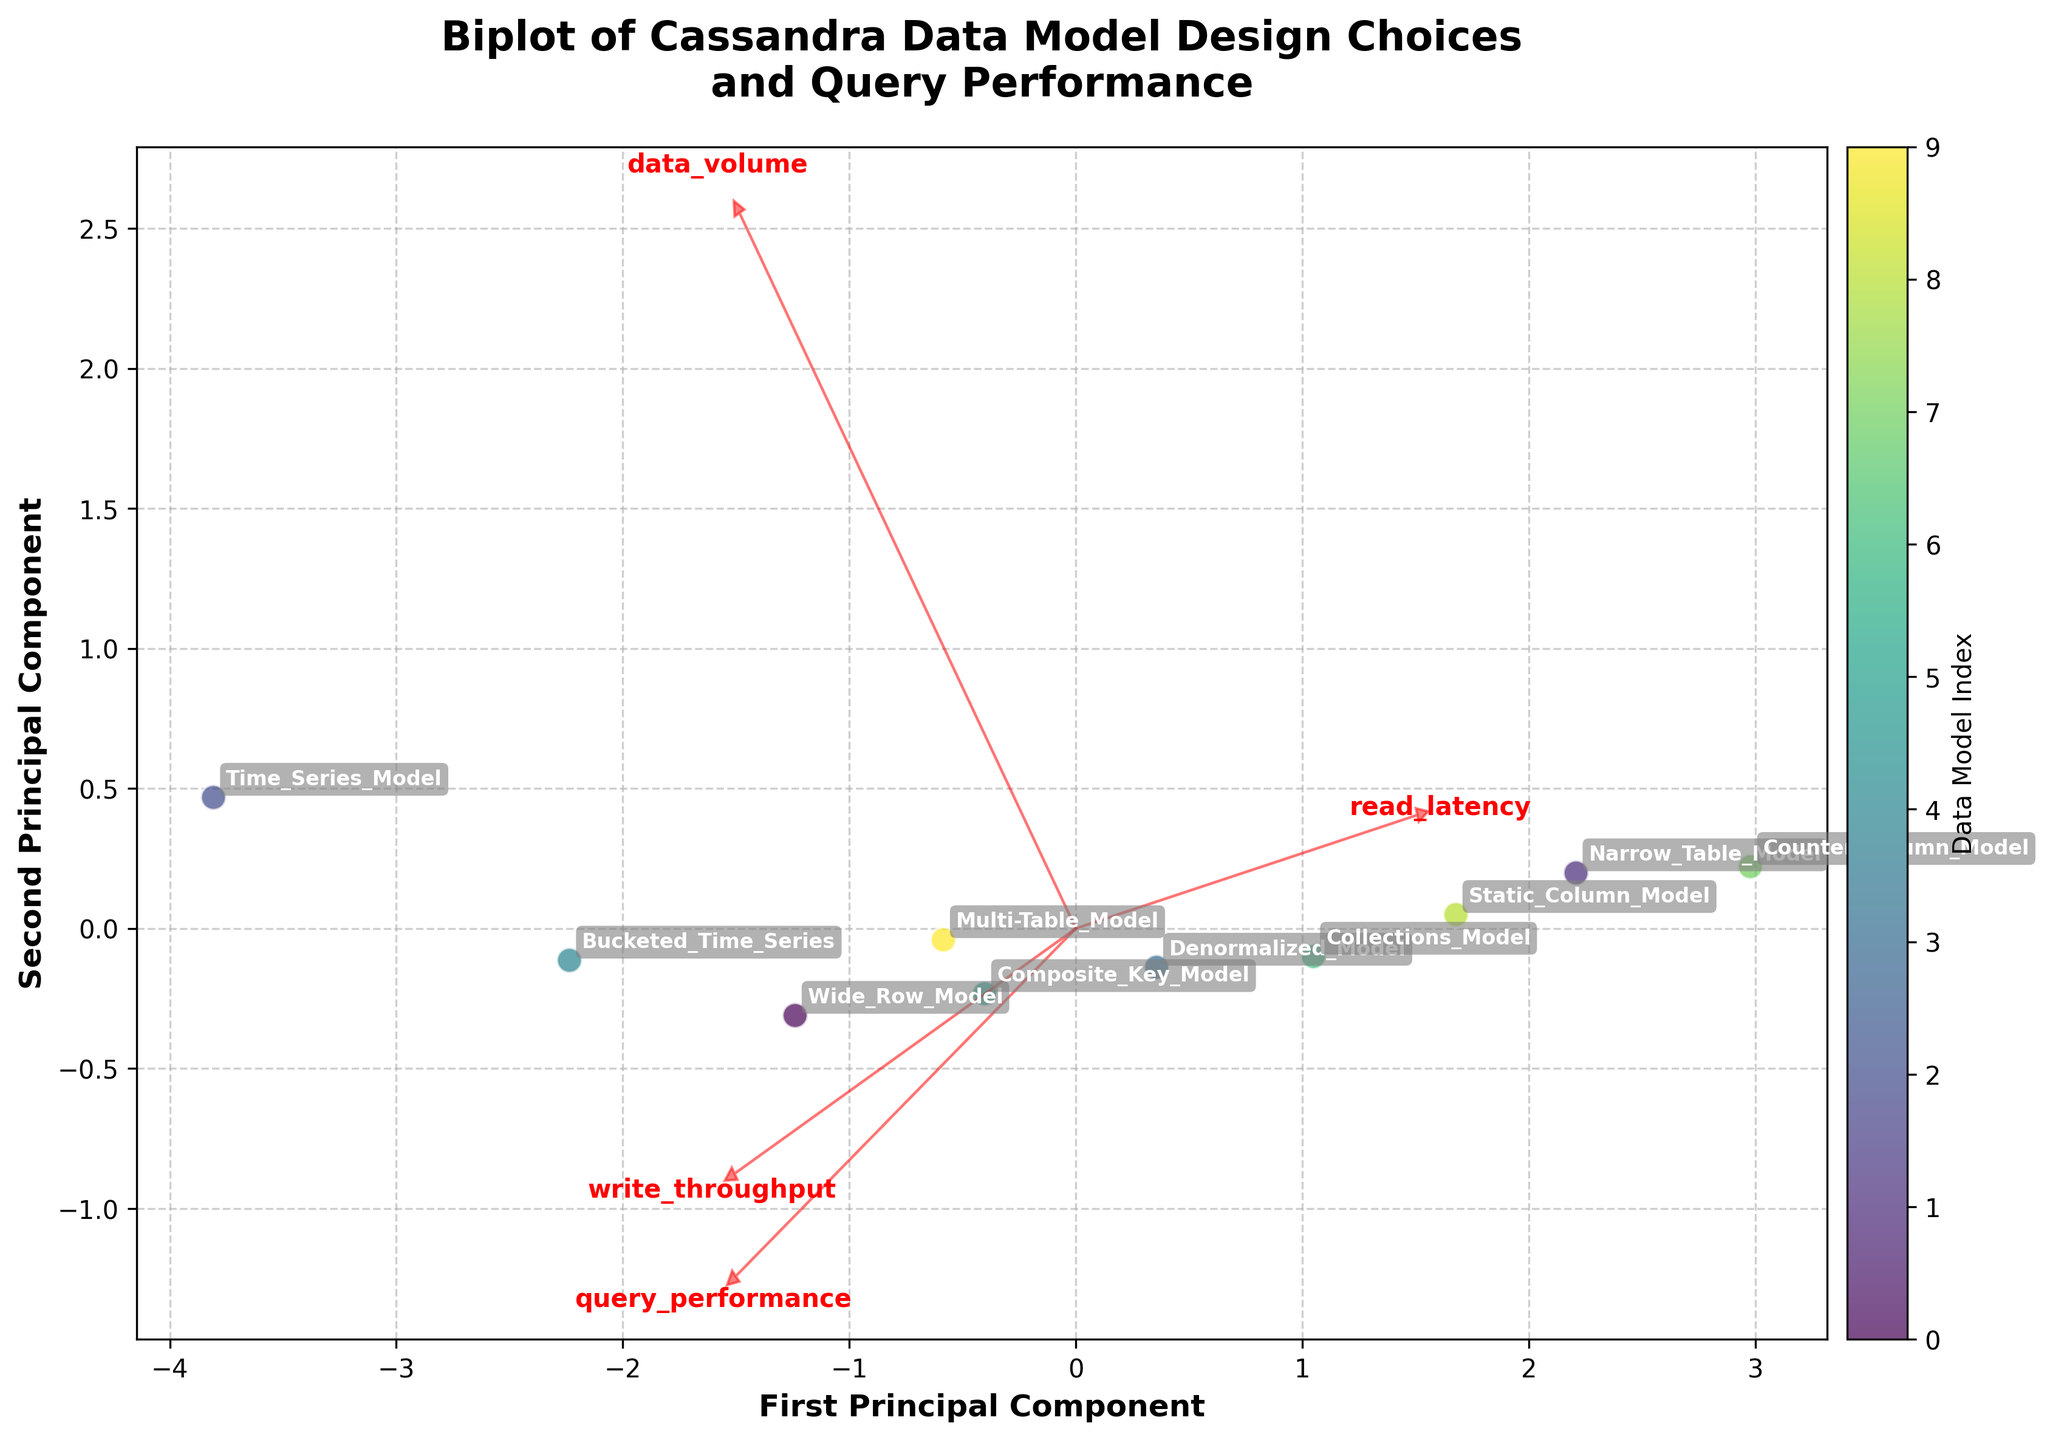What is the title of the plot? The title is typically found at the top of the plot, summarizing the information shown. Here, the title says "Biplot of Cassandra Data Model Design Choices and Query Performance,” which indicates the plot compares different data models and their performance characteristics.
Answer: Biplot of Cassandra Data Model Design Choices and Query Performance How many data models are represented in the plot? The data points in the scatter plot each represent a different data model; their names are annotated with the points. By counting these annotations, it is visible that there are 10 data models.
Answer: 10 Which data model shows the highest query performance? The scatter plot's data points are associated with different data models, and the query performance is represented by these points. By checking the labels and positions, the "Time_Series_Model" is furthest towards the high query performance area.
Answer: Time_Series_Model Which features do the arrows in the biplot represent? Arrows in a biplot typically represent the features from the original dataset. Here, four arrows emanate from the origin, each labeled one of the features: "query_performance," "data_volume," "read_latency," and "write_throughput."
Answer: query_performance, data_volume, read_latency, and write_throughput How do you determine which data model has the lowest read latency? Read latency is one of the features represented in the plot. By observing the arrow direction and scaling for "read_latency," we find the model furthest in the negative direction of this vector is the "Time_Series_Model."
Answer: Time_Series_Model Which data model generally balances between query performance and write throughput effectively? Balancing between query performance and write throughput means looking for a data model positioned somewhat centrally between the vectors for these features. The "Composite_Key_Model" appears well-balanced between these metrics based on its position.
Answer: Composite_Key_Model How does the "Bucketed_Time_Series" model compare to the "Narrow_Table_Model" in terms of data volume and read latency? By examining the arrows and positions relative to the vectors "data_volume" and "read_latency," the "Bucketed_Time_Series" model has higher data volume (further along the data volume arrow) and lower read latency (closer to the negative read latency vector) compared to the "Narrow_Table_Model."
Answer: Higher data volume, lower read latency Which principal component explains more variance, the first or the second? The labels of the axes typically indicate the principal components (PC1 and PC2) by their naming convention and explain the variance through their scales. The x-axis, labeled "First Principal Component," is likely to explain more variance as it’s usually the case in biplots.
Answer: First Principal Component Do the "Denormalized_Model" and "Static_Column_Model" data models lie close to each other in the biplot? By visually comparing the annotative positions of "Denormalized_Model" and "Static_Column_Model," if their labels and points are close in proximity on the plot, they can be considered close to each other.
Answer: Yes Which feature is most positively correlated with the "Time_Series_Model"? To determine this, analyze the "Time_Series_Model" position relative to the feature arrows. It is closest to and most aligned with the "write_throughput" vector, indicating a strong positive correlation with write throughput.
Answer: write_throughput 